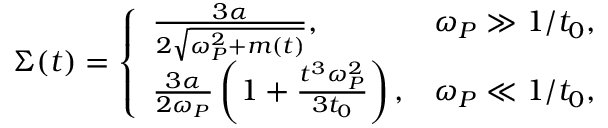Convert formula to latex. <formula><loc_0><loc_0><loc_500><loc_500>\begin{array} { r } { \Sigma ( t ) = \left \{ \begin{array} { l r } { \frac { { 3 } \alpha } { { 2 } \sqrt { \omega _ { P } ^ { 2 } + m ( t ) } } , } & { \omega _ { P } \gg 1 / t _ { 0 } , } \\ { \frac { { 3 } \alpha } { { 2 } \omega _ { P } } \left ( 1 + \frac { t ^ { 3 } \omega _ { P } ^ { 2 } } { 3 t _ { 0 } } \right ) , } & { \omega _ { P } \ll 1 / t _ { 0 } , } \end{array} } \end{array}</formula> 